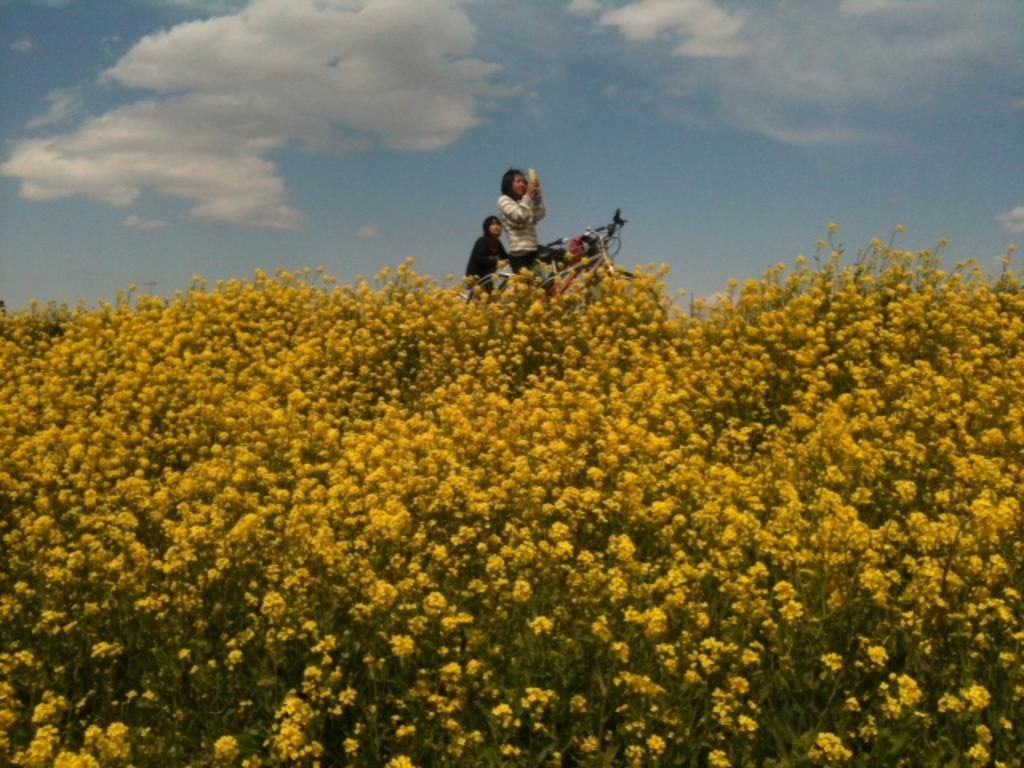What is located at the bottom of the image? There are plants at the bottom of the image. What can be seen behind the plants? There are people standing behind the plants. What type of transportation is visible in the image? There are bicycles visible in the image. What is visible in the sky in the image? There are clouds in the sky, and the sky is visible in the image. How does the instrument help the boats in the image? There are no boats or instruments present in the image. What direction do the people turn while standing behind the plants? The image does not provide information about the people turning in any direction; they are simply standing behind the plants. 